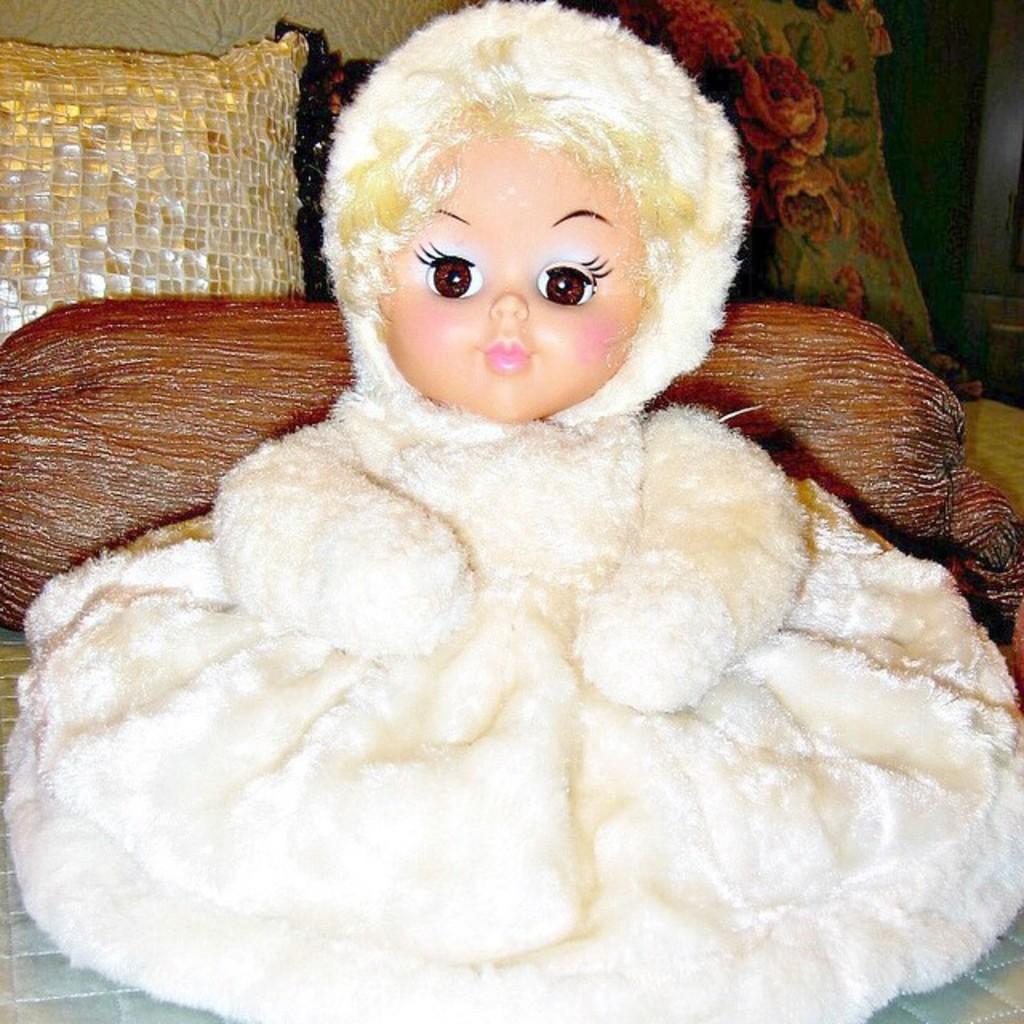Could you give a brief overview of what you see in this image? This image consists of a doll. In the background, there are cushions and a pillow. At the bottom, it looks like a bed. 